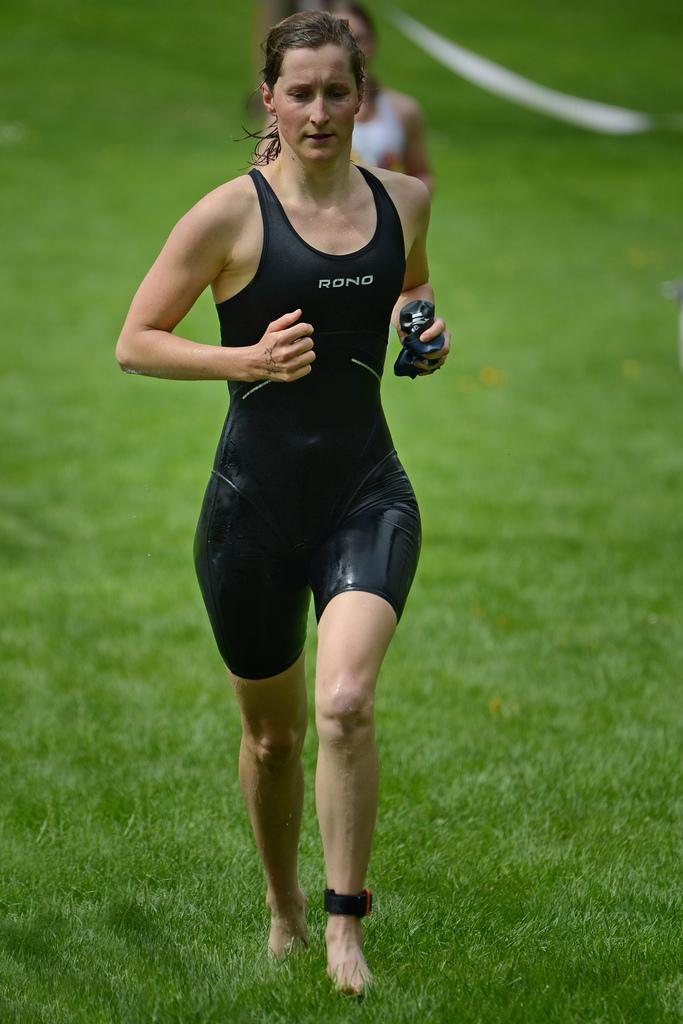Can you describe this image briefly? In this picture there is a woman with black t-shirt is running at the back there is a woman with white t-shirt and at the bottom there is grass. 